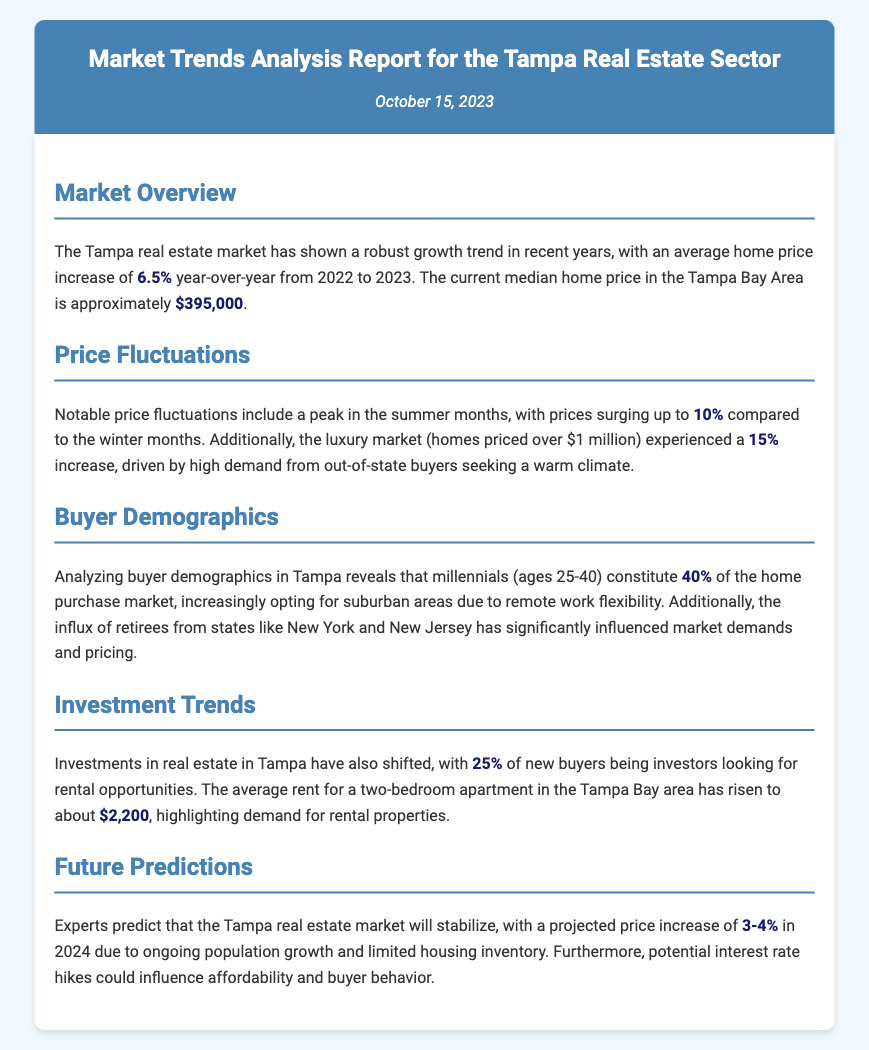What is the average home price increase from 2022 to 2023? The document states that the average home price increase is 6.5% year-over-year from 2022 to 2023.
Answer: 6.5% What is the current median home price in the Tampa Bay Area? The current median home price mentioned in the document is approximately $395,000.
Answer: $395,000 What is the percentage increase in the luxury market (homes over $1 million)? The document notes a 15% increase in the luxury market driven by out-of-state buyers.
Answer: 15% Which age group constitutes 40% of the home purchase market? According to the document, millennials (ages 25-40) constitute 40% of the home purchase market.
Answer: millennials (ages 25-40) What is the average rent for a two-bedroom apartment in the Tampa Bay area? The average rent mentioned in the document is about $2,200 for a two-bedroom apartment.
Answer: $2,200 What is the projected price increase for the Tampa real estate market in 2024? The document predicts a price increase of 3-4% in 2024 for the Tampa real estate market.
Answer: 3-4% How much of the new buyers in Tampa are investors? According to the document, 25% of new buyers are investors looking for rental opportunities.
Answer: 25% What factor is influencing buyer behavior according to future predictions? The document indicates that potential interest rate hikes could influence affordability and buyer behavior.
Answer: interest rate hikes Why are millennials increasingly opting for suburban areas? The document states that millennials are increasingly opting for suburban areas due to remote work flexibility.
Answer: remote work flexibility 